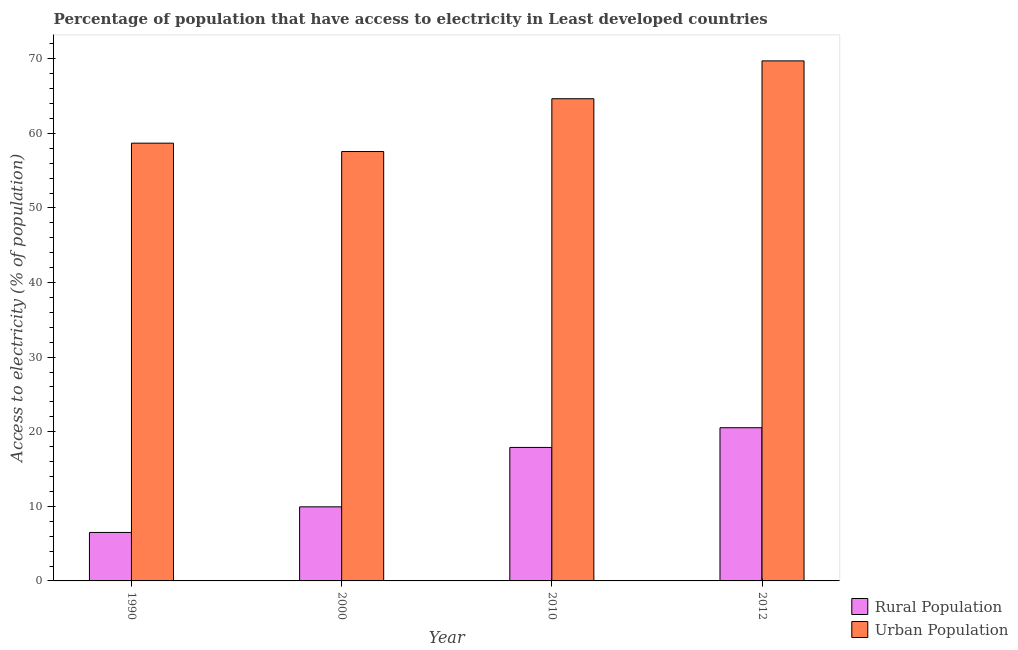How many different coloured bars are there?
Provide a succinct answer. 2. How many groups of bars are there?
Your answer should be very brief. 4. Are the number of bars per tick equal to the number of legend labels?
Your response must be concise. Yes. How many bars are there on the 2nd tick from the right?
Your answer should be compact. 2. In how many cases, is the number of bars for a given year not equal to the number of legend labels?
Keep it short and to the point. 0. What is the percentage of rural population having access to electricity in 2010?
Keep it short and to the point. 17.89. Across all years, what is the maximum percentage of rural population having access to electricity?
Provide a short and direct response. 20.54. Across all years, what is the minimum percentage of rural population having access to electricity?
Your response must be concise. 6.5. In which year was the percentage of urban population having access to electricity maximum?
Give a very brief answer. 2012. In which year was the percentage of urban population having access to electricity minimum?
Give a very brief answer. 2000. What is the total percentage of rural population having access to electricity in the graph?
Offer a terse response. 54.86. What is the difference between the percentage of urban population having access to electricity in 1990 and that in 2010?
Provide a succinct answer. -5.96. What is the difference between the percentage of rural population having access to electricity in 1990 and the percentage of urban population having access to electricity in 2012?
Provide a succinct answer. -14.04. What is the average percentage of urban population having access to electricity per year?
Your response must be concise. 62.65. In the year 2010, what is the difference between the percentage of urban population having access to electricity and percentage of rural population having access to electricity?
Offer a terse response. 0. What is the ratio of the percentage of urban population having access to electricity in 1990 to that in 2012?
Your response must be concise. 0.84. Is the percentage of urban population having access to electricity in 2000 less than that in 2010?
Provide a succinct answer. Yes. Is the difference between the percentage of urban population having access to electricity in 2000 and 2012 greater than the difference between the percentage of rural population having access to electricity in 2000 and 2012?
Your answer should be very brief. No. What is the difference between the highest and the second highest percentage of urban population having access to electricity?
Keep it short and to the point. 5.07. What is the difference between the highest and the lowest percentage of urban population having access to electricity?
Your response must be concise. 12.15. In how many years, is the percentage of urban population having access to electricity greater than the average percentage of urban population having access to electricity taken over all years?
Keep it short and to the point. 2. What does the 1st bar from the left in 2010 represents?
Your response must be concise. Rural Population. What does the 1st bar from the right in 2010 represents?
Ensure brevity in your answer.  Urban Population. Are all the bars in the graph horizontal?
Keep it short and to the point. No. How many years are there in the graph?
Your answer should be compact. 4. Does the graph contain grids?
Provide a short and direct response. No. What is the title of the graph?
Make the answer very short. Percentage of population that have access to electricity in Least developed countries. What is the label or title of the Y-axis?
Provide a succinct answer. Access to electricity (% of population). What is the Access to electricity (% of population) in Rural Population in 1990?
Your response must be concise. 6.5. What is the Access to electricity (% of population) of Urban Population in 1990?
Your response must be concise. 58.68. What is the Access to electricity (% of population) of Rural Population in 2000?
Give a very brief answer. 9.93. What is the Access to electricity (% of population) in Urban Population in 2000?
Offer a very short reply. 57.56. What is the Access to electricity (% of population) of Rural Population in 2010?
Provide a succinct answer. 17.89. What is the Access to electricity (% of population) in Urban Population in 2010?
Provide a succinct answer. 64.64. What is the Access to electricity (% of population) in Rural Population in 2012?
Provide a succinct answer. 20.54. What is the Access to electricity (% of population) of Urban Population in 2012?
Ensure brevity in your answer.  69.71. Across all years, what is the maximum Access to electricity (% of population) in Rural Population?
Make the answer very short. 20.54. Across all years, what is the maximum Access to electricity (% of population) in Urban Population?
Your response must be concise. 69.71. Across all years, what is the minimum Access to electricity (% of population) in Rural Population?
Make the answer very short. 6.5. Across all years, what is the minimum Access to electricity (% of population) in Urban Population?
Keep it short and to the point. 57.56. What is the total Access to electricity (% of population) of Rural Population in the graph?
Offer a terse response. 54.86. What is the total Access to electricity (% of population) of Urban Population in the graph?
Offer a terse response. 250.59. What is the difference between the Access to electricity (% of population) of Rural Population in 1990 and that in 2000?
Provide a succinct answer. -3.43. What is the difference between the Access to electricity (% of population) in Urban Population in 1990 and that in 2000?
Offer a very short reply. 1.12. What is the difference between the Access to electricity (% of population) in Rural Population in 1990 and that in 2010?
Keep it short and to the point. -11.4. What is the difference between the Access to electricity (% of population) of Urban Population in 1990 and that in 2010?
Keep it short and to the point. -5.96. What is the difference between the Access to electricity (% of population) in Rural Population in 1990 and that in 2012?
Give a very brief answer. -14.04. What is the difference between the Access to electricity (% of population) of Urban Population in 1990 and that in 2012?
Give a very brief answer. -11.03. What is the difference between the Access to electricity (% of population) of Rural Population in 2000 and that in 2010?
Offer a terse response. -7.96. What is the difference between the Access to electricity (% of population) in Urban Population in 2000 and that in 2010?
Make the answer very short. -7.08. What is the difference between the Access to electricity (% of population) in Rural Population in 2000 and that in 2012?
Your answer should be compact. -10.6. What is the difference between the Access to electricity (% of population) of Urban Population in 2000 and that in 2012?
Your response must be concise. -12.15. What is the difference between the Access to electricity (% of population) in Rural Population in 2010 and that in 2012?
Provide a short and direct response. -2.64. What is the difference between the Access to electricity (% of population) of Urban Population in 2010 and that in 2012?
Offer a terse response. -5.07. What is the difference between the Access to electricity (% of population) in Rural Population in 1990 and the Access to electricity (% of population) in Urban Population in 2000?
Your answer should be very brief. -51.06. What is the difference between the Access to electricity (% of population) in Rural Population in 1990 and the Access to electricity (% of population) in Urban Population in 2010?
Your answer should be very brief. -58.14. What is the difference between the Access to electricity (% of population) of Rural Population in 1990 and the Access to electricity (% of population) of Urban Population in 2012?
Provide a short and direct response. -63.21. What is the difference between the Access to electricity (% of population) of Rural Population in 2000 and the Access to electricity (% of population) of Urban Population in 2010?
Your answer should be very brief. -54.71. What is the difference between the Access to electricity (% of population) of Rural Population in 2000 and the Access to electricity (% of population) of Urban Population in 2012?
Ensure brevity in your answer.  -59.78. What is the difference between the Access to electricity (% of population) in Rural Population in 2010 and the Access to electricity (% of population) in Urban Population in 2012?
Give a very brief answer. -51.82. What is the average Access to electricity (% of population) of Rural Population per year?
Make the answer very short. 13.71. What is the average Access to electricity (% of population) of Urban Population per year?
Your answer should be very brief. 62.65. In the year 1990, what is the difference between the Access to electricity (% of population) in Rural Population and Access to electricity (% of population) in Urban Population?
Ensure brevity in your answer.  -52.18. In the year 2000, what is the difference between the Access to electricity (% of population) in Rural Population and Access to electricity (% of population) in Urban Population?
Your answer should be very brief. -47.63. In the year 2010, what is the difference between the Access to electricity (% of population) in Rural Population and Access to electricity (% of population) in Urban Population?
Give a very brief answer. -46.74. In the year 2012, what is the difference between the Access to electricity (% of population) in Rural Population and Access to electricity (% of population) in Urban Population?
Your response must be concise. -49.18. What is the ratio of the Access to electricity (% of population) in Rural Population in 1990 to that in 2000?
Your answer should be very brief. 0.65. What is the ratio of the Access to electricity (% of population) in Urban Population in 1990 to that in 2000?
Make the answer very short. 1.02. What is the ratio of the Access to electricity (% of population) of Rural Population in 1990 to that in 2010?
Your answer should be very brief. 0.36. What is the ratio of the Access to electricity (% of population) in Urban Population in 1990 to that in 2010?
Provide a succinct answer. 0.91. What is the ratio of the Access to electricity (% of population) of Rural Population in 1990 to that in 2012?
Give a very brief answer. 0.32. What is the ratio of the Access to electricity (% of population) of Urban Population in 1990 to that in 2012?
Your answer should be compact. 0.84. What is the ratio of the Access to electricity (% of population) in Rural Population in 2000 to that in 2010?
Your answer should be compact. 0.56. What is the ratio of the Access to electricity (% of population) of Urban Population in 2000 to that in 2010?
Your answer should be compact. 0.89. What is the ratio of the Access to electricity (% of population) of Rural Population in 2000 to that in 2012?
Provide a short and direct response. 0.48. What is the ratio of the Access to electricity (% of population) of Urban Population in 2000 to that in 2012?
Provide a succinct answer. 0.83. What is the ratio of the Access to electricity (% of population) of Rural Population in 2010 to that in 2012?
Your answer should be compact. 0.87. What is the ratio of the Access to electricity (% of population) of Urban Population in 2010 to that in 2012?
Give a very brief answer. 0.93. What is the difference between the highest and the second highest Access to electricity (% of population) in Rural Population?
Your answer should be very brief. 2.64. What is the difference between the highest and the second highest Access to electricity (% of population) of Urban Population?
Make the answer very short. 5.07. What is the difference between the highest and the lowest Access to electricity (% of population) of Rural Population?
Your response must be concise. 14.04. What is the difference between the highest and the lowest Access to electricity (% of population) in Urban Population?
Give a very brief answer. 12.15. 